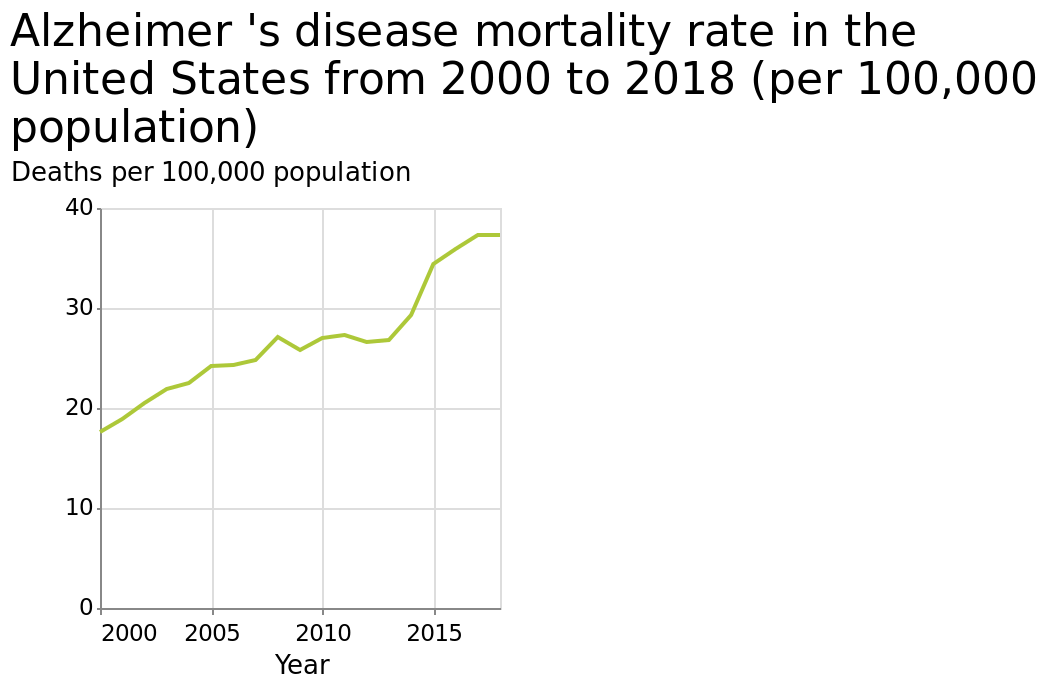<image>
What has been happening to the number of deaths?  There has been a steady increase in deaths. What is the maximum value on the y-axis? The maximum value on the y-axis is 40 Deaths per 100,000 population. 